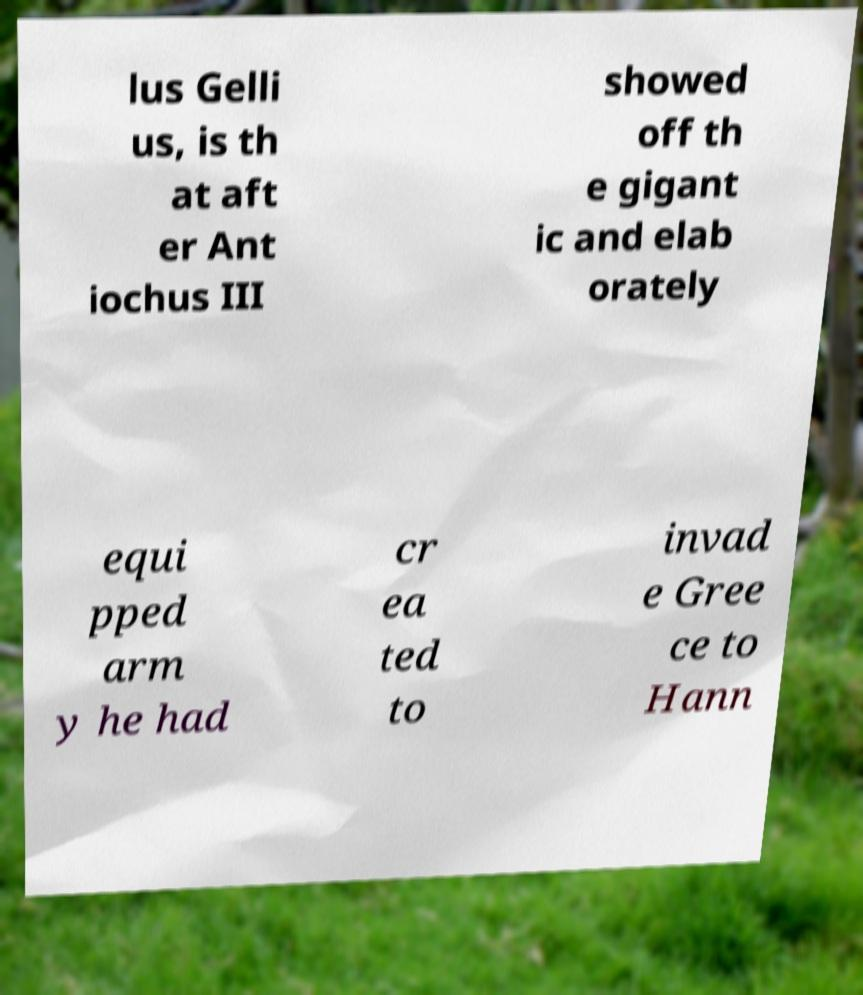There's text embedded in this image that I need extracted. Can you transcribe it verbatim? lus Gelli us, is th at aft er Ant iochus III showed off th e gigant ic and elab orately equi pped arm y he had cr ea ted to invad e Gree ce to Hann 